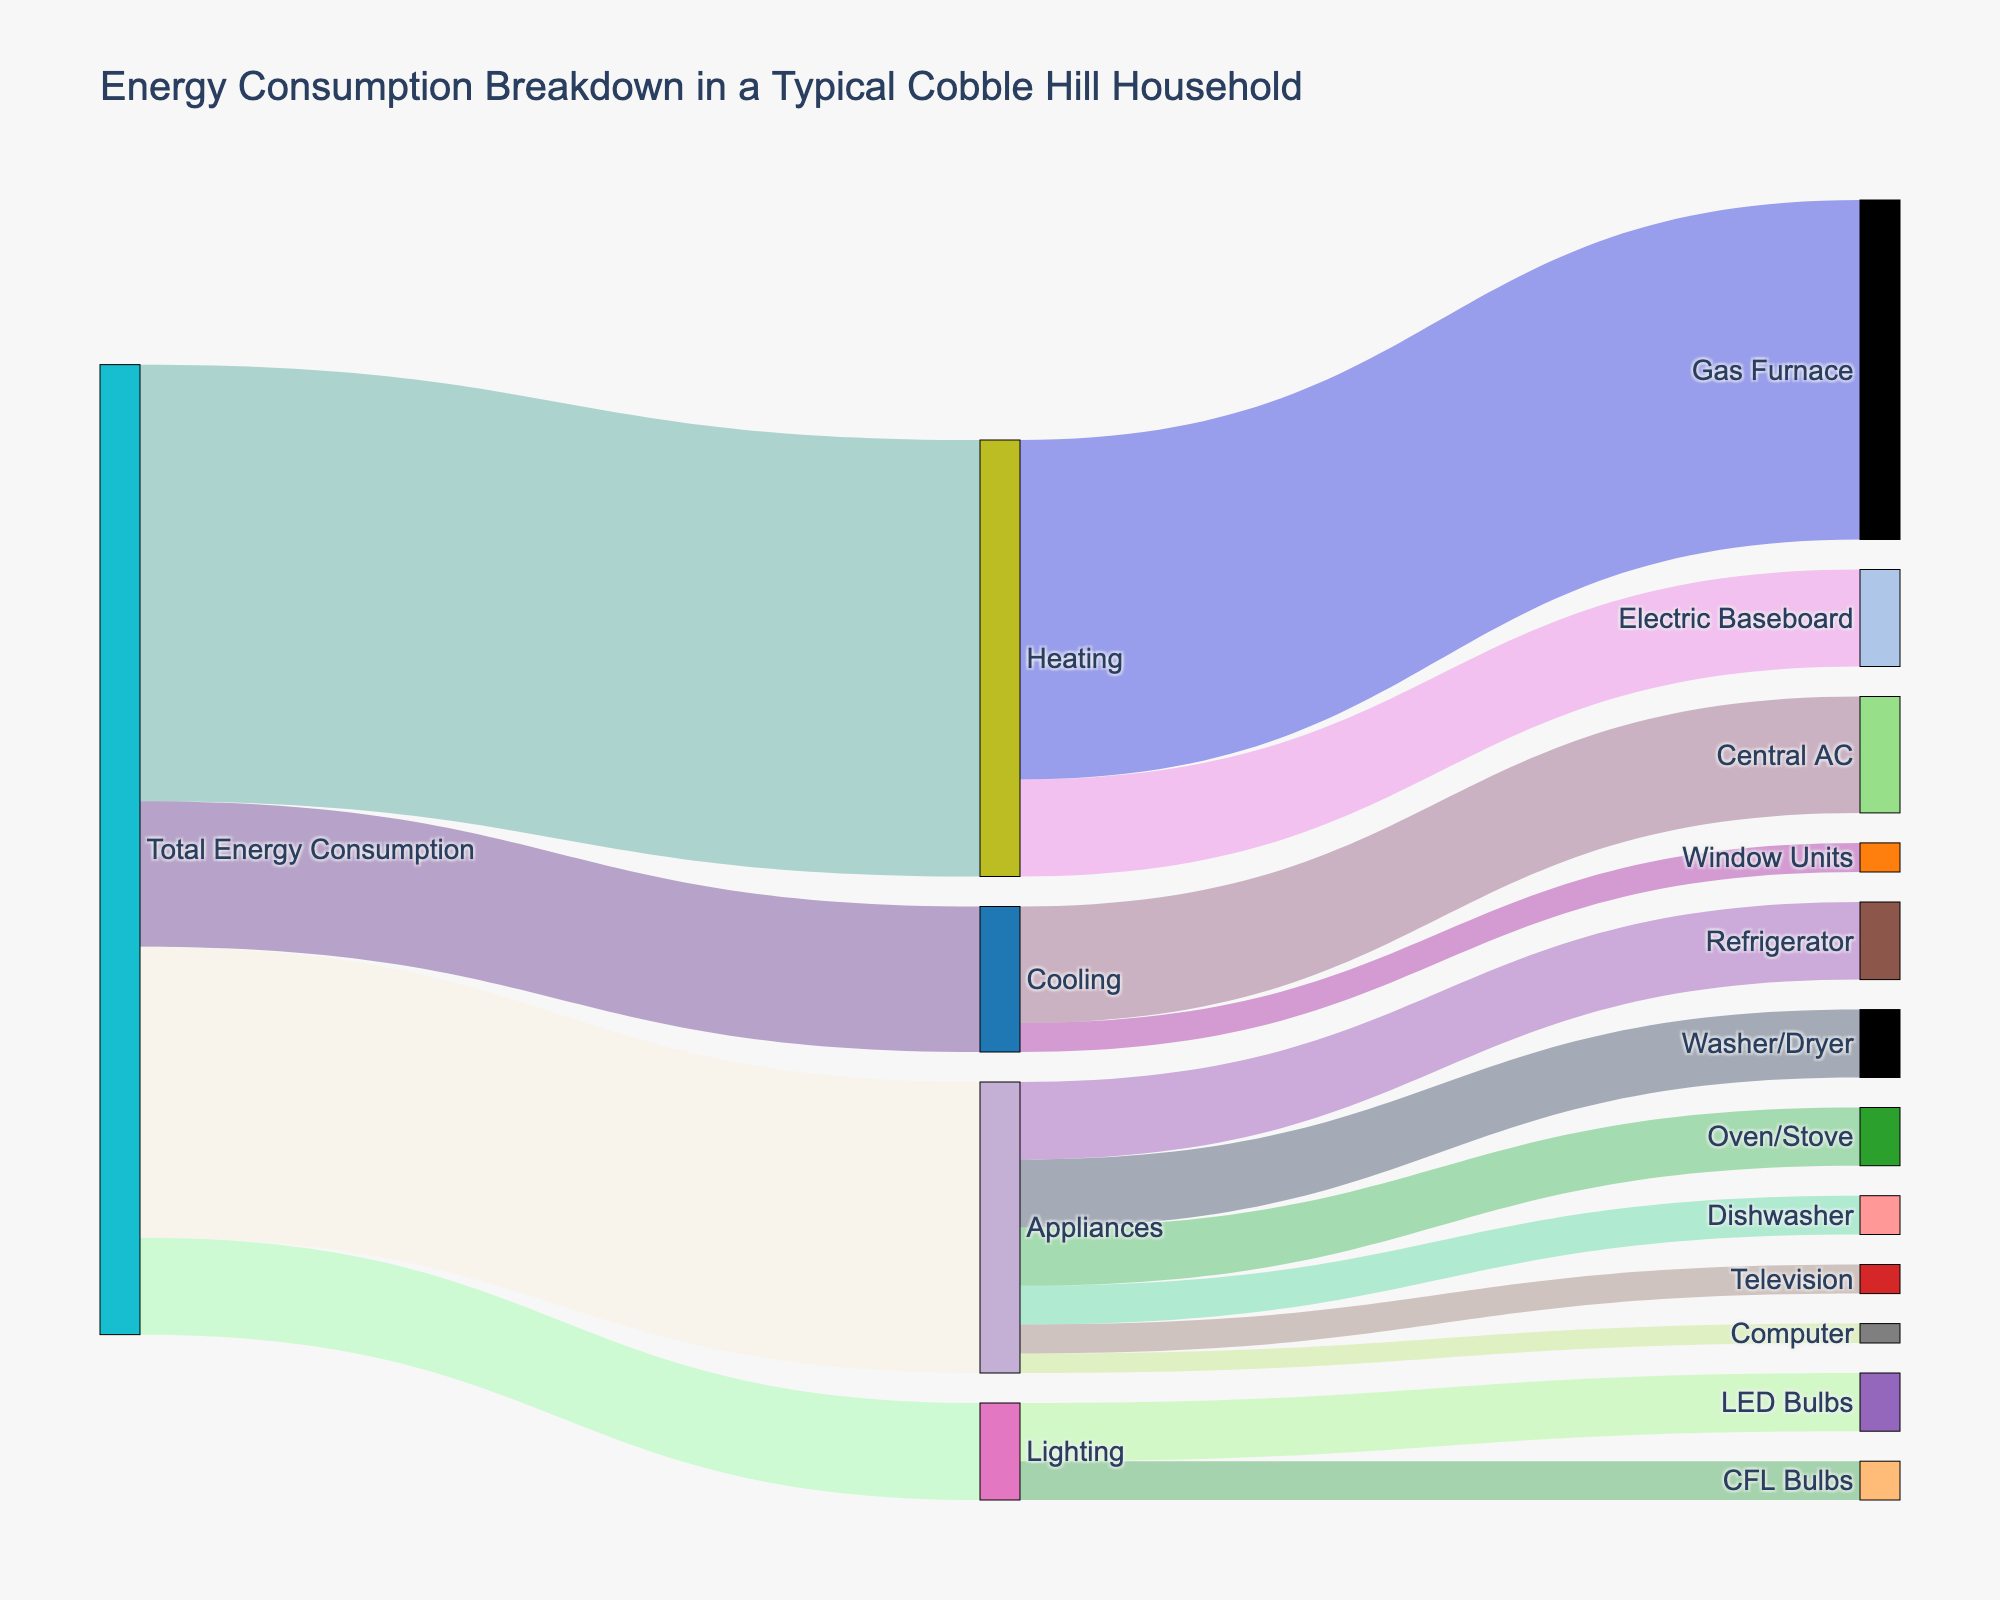What percentage of the household's total energy consumption is used for heating? The figure shows that the total energy consumption is divided into heating, cooling, appliances, and lighting. Heating uses 45 units out of the total 100 units consumed (the sum of heating, cooling, appliances, and lighting values). Therefore, the percentage for heating is (45 / 100) * 100 = 45%.
Answer: 45% Which category uses more energy, appliances or cooling? According to the figure, appliances consume 30 units of energy while cooling consumes 15 units. Since 30 is greater than 15, appliances use more energy.
Answer: Appliances How much more energy is used for the refrigerator compared to the computer? By checking the values under the appliances category, the refrigerator uses 8 units, and the computer uses 2 units. The difference is 8 - 2 = 6 units.
Answer: 6 units What is the combined energy consumption of the gas furnace and the central AC? The figure shows that the gas furnace uses 35 units, and the central AC uses 12 units. Adding these values gives 35 + 12 = 47 units.
Answer: 47 units Which lighting method consumes the least energy? The figure indicates two options for lighting: LED bulbs and CFL bulbs. LED bulbs consume 6 units, while CFL bulbs consume 4 units. Therefore, CFL bulbs consume the least energy.
Answer: CFL bulbs What fraction of heating energy is supplied by the gas furnace? Heating consumes 45 units in total, with the gas furnace using 35 units. The fraction is 35 / 45. Simplifying, we get 7/9.
Answer: 7/9 How does the energy consumption of window units compare to electric baseboard heating? The figure shows that window units consume 3 units of energy and electric baseboard heating consumes 10 units. Since 3 is less than 10, window units consume less energy.
Answer: Window units consume less What is the total energy consumption of the appliances listed in the figure? Adding up the energy consumption for the refrigerator, washer/dryer, oven/stove, dishwasher, television, and computer: 8 + 7 + 6 + 4 + 3 + 2 = 30 units.
Answer: 30 units Is the energy consumed by cooling greater or less than half of that consumed by heating? Cooling consumes 15 units and heating consumes 45 units. Half of the heating energy is 45 / 2 = 22.5 units. Since 15 is less than 22.5, cooling consumes less than half of heating energy.
Answer: Less What proportion of total energy consumption is used by lighting? The figure indicates that lighting uses 10 units of energy out of a total of 100 units. The proportion is 10 / 100, which simplifies to 1/10 or 10%.
Answer: 10% 